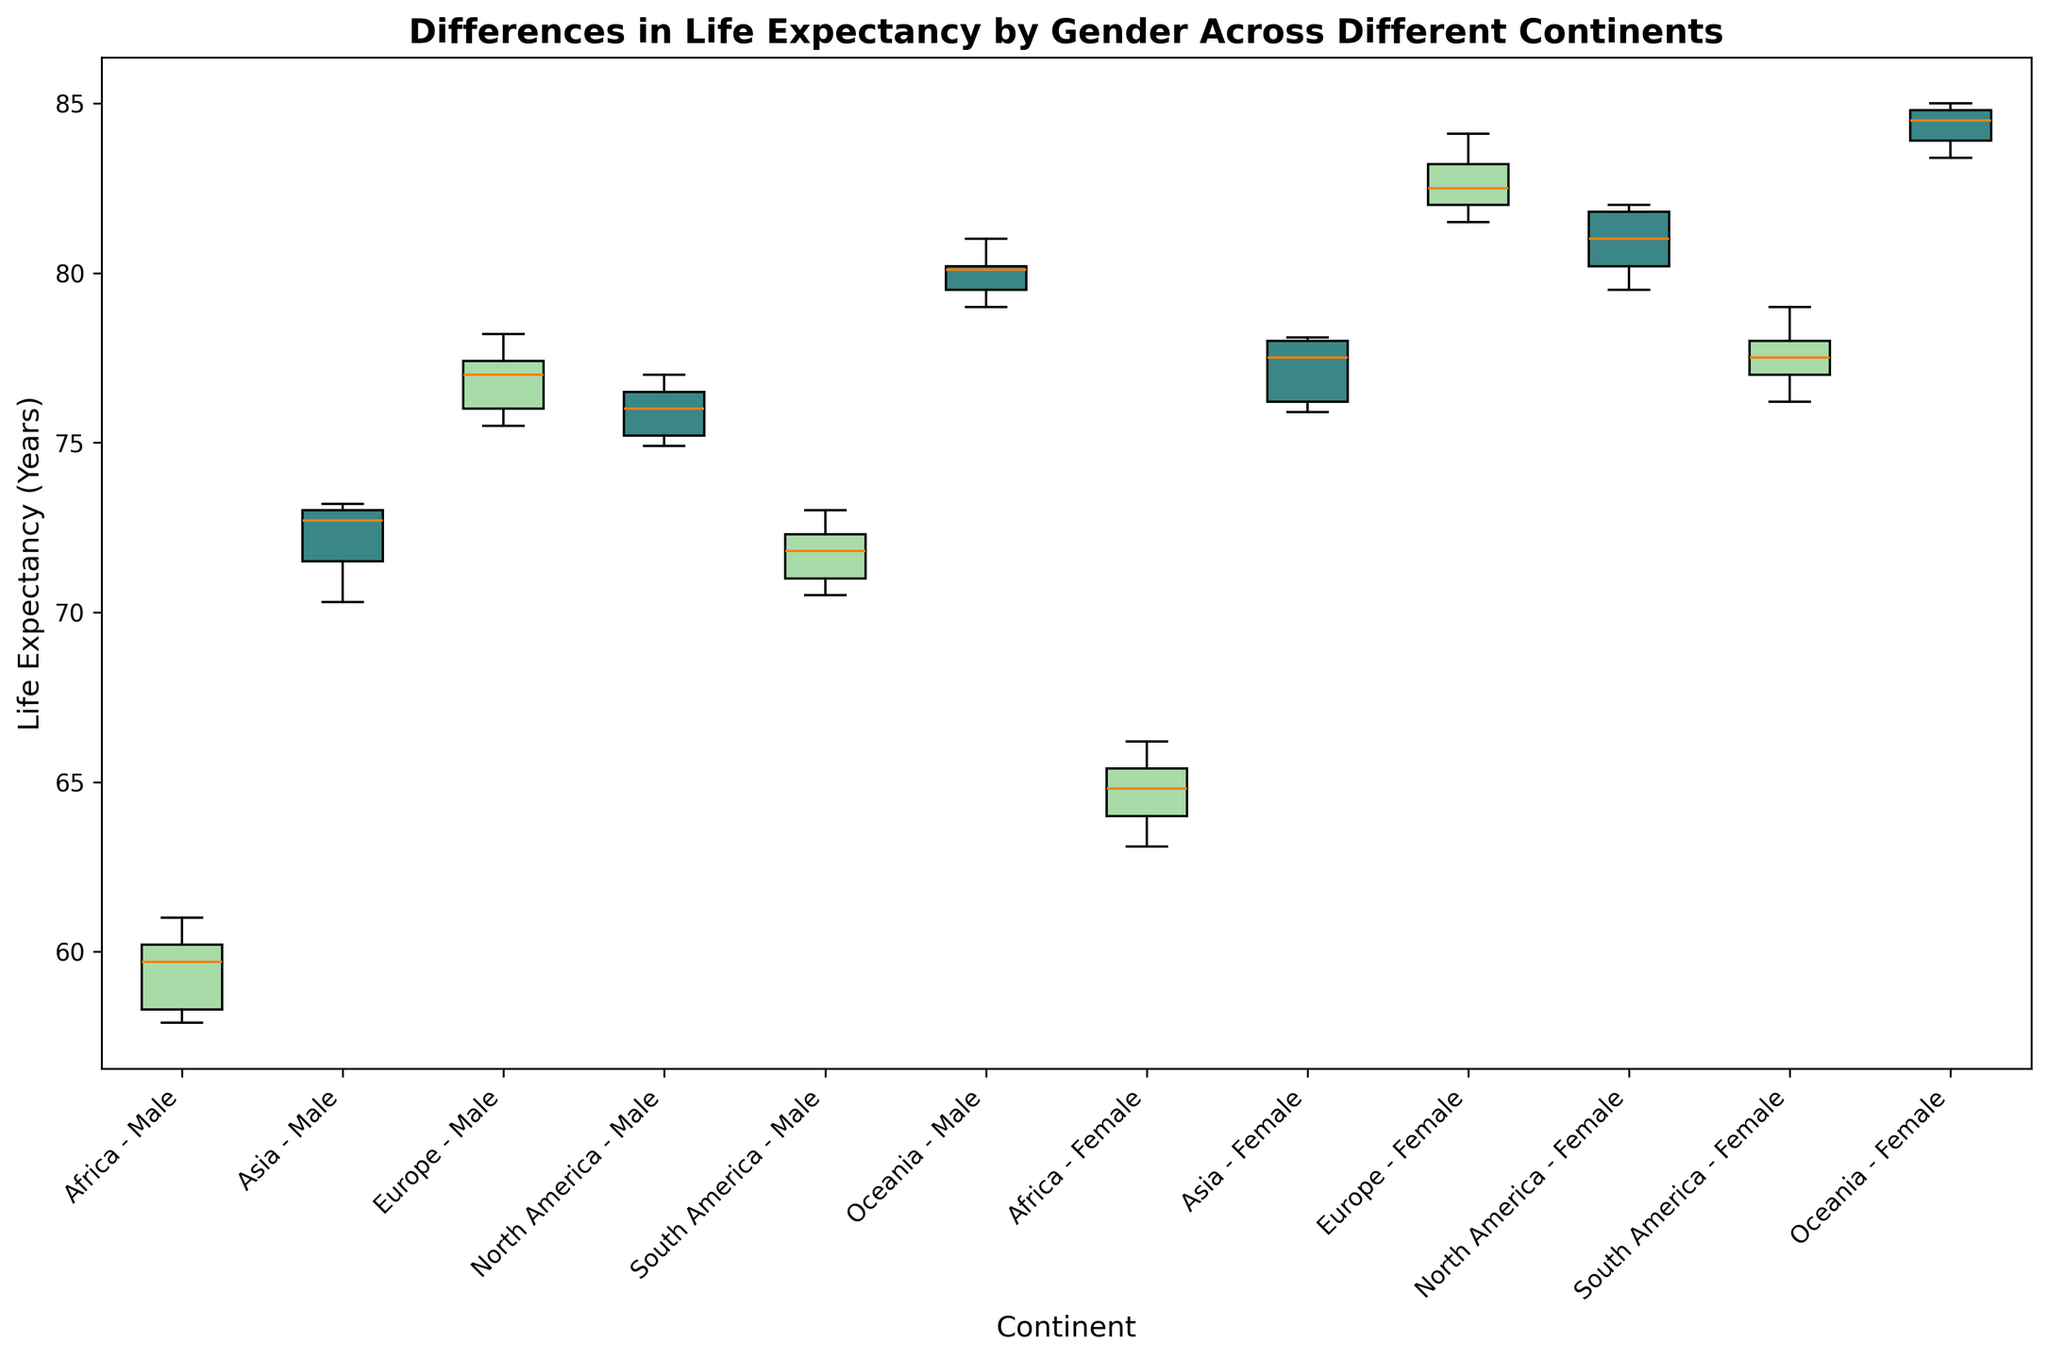Which continent has the highest median life expectancy for males? From the box plot, observe the median line inside the box for each male group. The highest median line represents the highest median life expectancy. Oceania's male median line is the highest.
Answer: Oceania How does the median life expectancy for females in Asia compare to that in Africa? Look at the median lines inside the boxes for Asia - Female and Africa - Female. Compare their positions. The median life expectancy for females in Asia is higher than that in Africa.
Answer: Higher in Asia Which gender generally has a higher life expectancy in South America? Compare the median lines of the male and female box plots for South America. The median line for females is higher than for males.
Answer: Females Is the life expectancy range for males in North America wider or narrower compared to females in the same continent? Compare the lengths of the whiskers (range) for both males and females in North America. The longer whiskers indicate a wider range. Males have a wider range.
Answer: Wider for males Which two continents have the largest difference in median life expectancy for females? Identify the median lines for females in all continents. Find the two medians with the largest gap. Europe and Oceania have the highest and Africa has the lowest medians, making the largest difference between Oceania and Africa.
Answer: Oceania and Africa Does the life expectancy distribution for females in Oceania overlap with that of males? Check if the whiskers and boxes for females in Oceania still intersect the range of males in Oceania.
Answer: Yes, they overlap What visual attributes indicate the spread of life expectancy more explicitly in box plots? The spread of life expectancy is visualized by the length of the boxes (IQR) and the length of the whiskers (overall range). Longer boxes and whiskers reflect greater spread.
Answer: Length of boxes and whiskers 